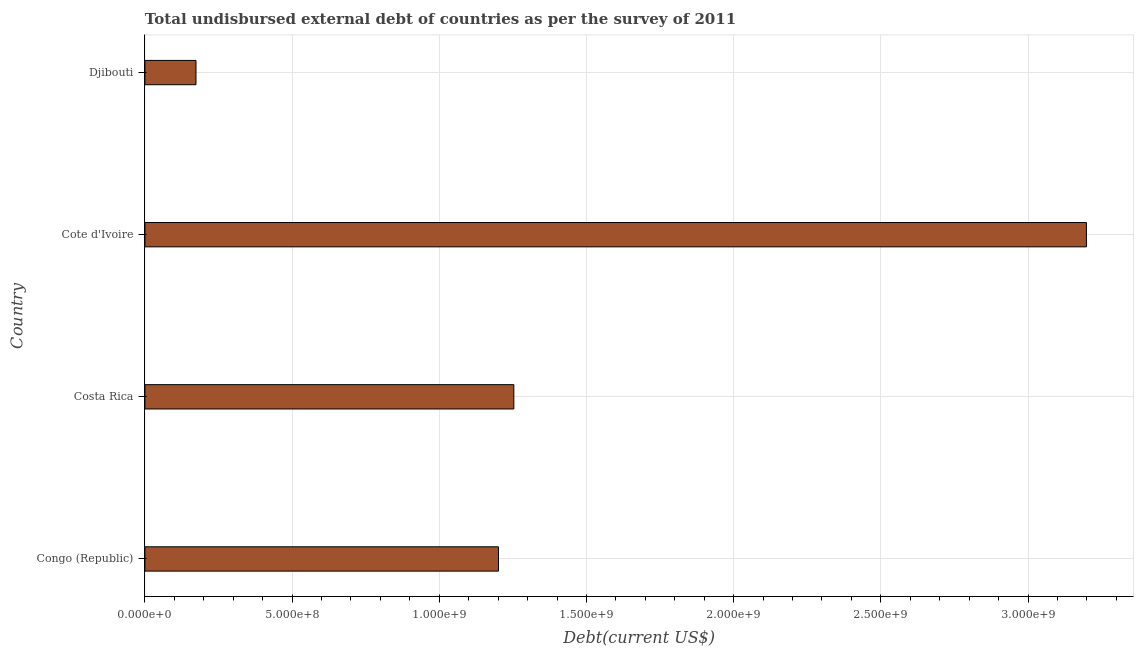What is the title of the graph?
Your answer should be compact. Total undisbursed external debt of countries as per the survey of 2011. What is the label or title of the X-axis?
Ensure brevity in your answer.  Debt(current US$). What is the total debt in Djibouti?
Make the answer very short. 1.73e+08. Across all countries, what is the maximum total debt?
Provide a short and direct response. 3.20e+09. Across all countries, what is the minimum total debt?
Ensure brevity in your answer.  1.73e+08. In which country was the total debt maximum?
Make the answer very short. Cote d'Ivoire. In which country was the total debt minimum?
Your answer should be compact. Djibouti. What is the sum of the total debt?
Provide a short and direct response. 5.83e+09. What is the difference between the total debt in Congo (Republic) and Costa Rica?
Give a very brief answer. -5.22e+07. What is the average total debt per country?
Give a very brief answer. 1.46e+09. What is the median total debt?
Offer a terse response. 1.23e+09. In how many countries, is the total debt greater than 2100000000 US$?
Give a very brief answer. 1. What is the ratio of the total debt in Congo (Republic) to that in Djibouti?
Ensure brevity in your answer.  6.92. Is the total debt in Congo (Republic) less than that in Costa Rica?
Make the answer very short. Yes. Is the difference between the total debt in Cote d'Ivoire and Djibouti greater than the difference between any two countries?
Your response must be concise. Yes. What is the difference between the highest and the second highest total debt?
Provide a succinct answer. 1.95e+09. What is the difference between the highest and the lowest total debt?
Offer a very short reply. 3.02e+09. In how many countries, is the total debt greater than the average total debt taken over all countries?
Give a very brief answer. 1. How many bars are there?
Provide a succinct answer. 4. How many countries are there in the graph?
Provide a succinct answer. 4. What is the difference between two consecutive major ticks on the X-axis?
Keep it short and to the point. 5.00e+08. Are the values on the major ticks of X-axis written in scientific E-notation?
Provide a short and direct response. Yes. What is the Debt(current US$) in Congo (Republic)?
Ensure brevity in your answer.  1.20e+09. What is the Debt(current US$) in Costa Rica?
Ensure brevity in your answer.  1.25e+09. What is the Debt(current US$) of Cote d'Ivoire?
Provide a succinct answer. 3.20e+09. What is the Debt(current US$) in Djibouti?
Keep it short and to the point. 1.73e+08. What is the difference between the Debt(current US$) in Congo (Republic) and Costa Rica?
Your response must be concise. -5.22e+07. What is the difference between the Debt(current US$) in Congo (Republic) and Cote d'Ivoire?
Ensure brevity in your answer.  -2.00e+09. What is the difference between the Debt(current US$) in Congo (Republic) and Djibouti?
Give a very brief answer. 1.03e+09. What is the difference between the Debt(current US$) in Costa Rica and Cote d'Ivoire?
Your response must be concise. -1.95e+09. What is the difference between the Debt(current US$) in Costa Rica and Djibouti?
Offer a terse response. 1.08e+09. What is the difference between the Debt(current US$) in Cote d'Ivoire and Djibouti?
Provide a short and direct response. 3.02e+09. What is the ratio of the Debt(current US$) in Congo (Republic) to that in Costa Rica?
Provide a succinct answer. 0.96. What is the ratio of the Debt(current US$) in Congo (Republic) to that in Cote d'Ivoire?
Your answer should be compact. 0.38. What is the ratio of the Debt(current US$) in Congo (Republic) to that in Djibouti?
Provide a succinct answer. 6.92. What is the ratio of the Debt(current US$) in Costa Rica to that in Cote d'Ivoire?
Provide a succinct answer. 0.39. What is the ratio of the Debt(current US$) in Costa Rica to that in Djibouti?
Keep it short and to the point. 7.22. What is the ratio of the Debt(current US$) in Cote d'Ivoire to that in Djibouti?
Make the answer very short. 18.43. 